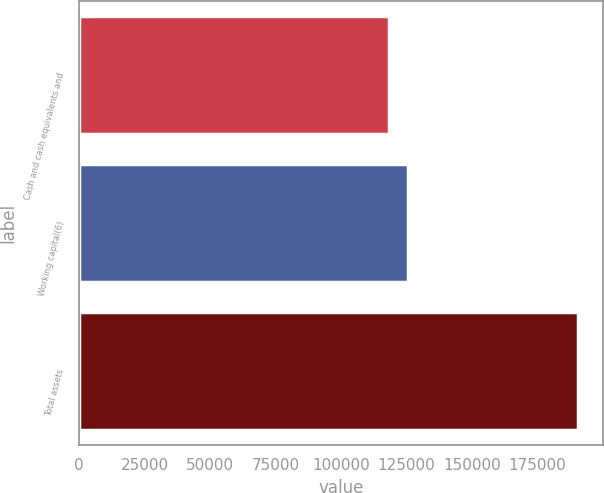Convert chart to OTSL. <chart><loc_0><loc_0><loc_500><loc_500><bar_chart><fcel>Cash and cash equivalents and<fcel>Working capital(6)<fcel>Total assets<nl><fcel>118145<fcel>125377<fcel>190462<nl></chart> 